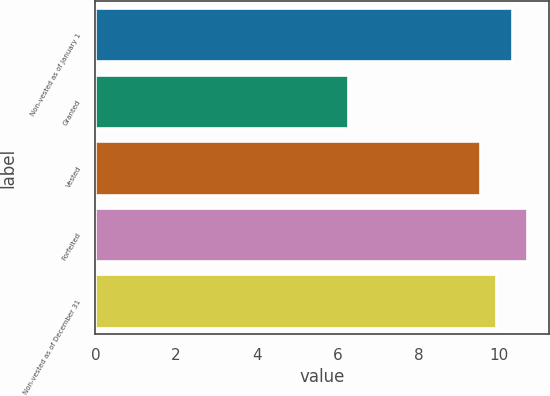Convert chart. <chart><loc_0><loc_0><loc_500><loc_500><bar_chart><fcel>Non-vested as of January 1<fcel>Granted<fcel>Vested<fcel>Forfeited<fcel>Non-vested as of December 31<nl><fcel>10.31<fcel>6.25<fcel>9.53<fcel>10.7<fcel>9.92<nl></chart> 